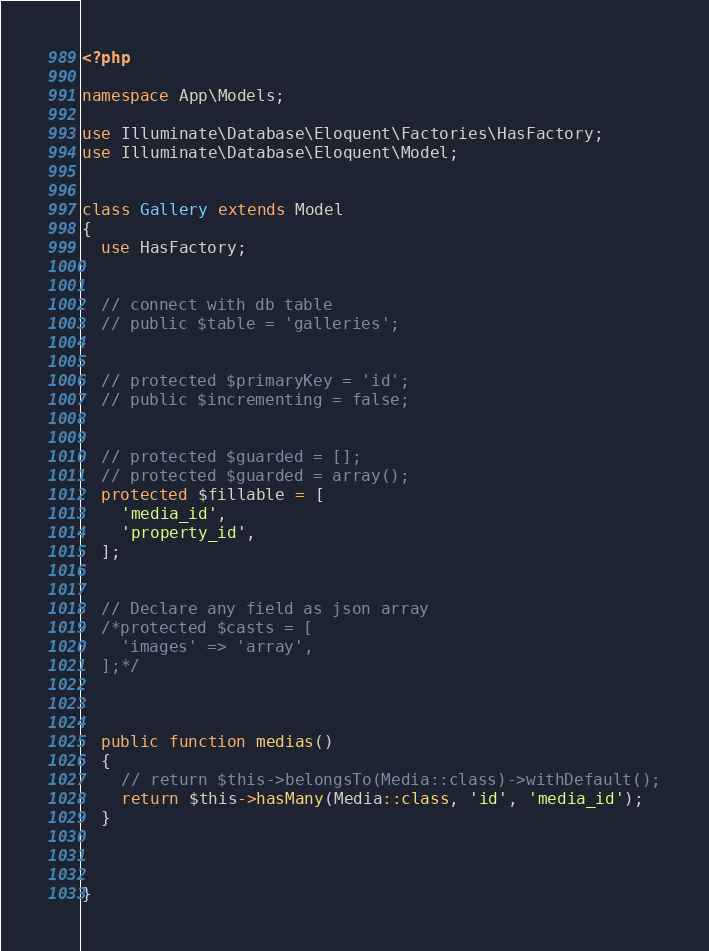Convert code to text. <code><loc_0><loc_0><loc_500><loc_500><_PHP_><?php

namespace App\Models;

use Illuminate\Database\Eloquent\Factories\HasFactory;
use Illuminate\Database\Eloquent\Model;


class Gallery extends Model
{
  use HasFactory;


  // connect with db table
  // public $table = 'galleries';


  // protected $primaryKey = 'id';
  // public $incrementing = false;


  // protected $guarded = [];
  // protected $guarded = array();
  protected $fillable = [
    'media_id',
    'property_id',
  ];


  // Declare any field as json array
  /*protected $casts = [
    'images' => 'array',
  ];*/


  
  public function medias()
  {
    // return $this->belongsTo(Media::class)->withDefault();
    return $this->hasMany(Media::class, 'id', 'media_id');
  }



}
</code> 